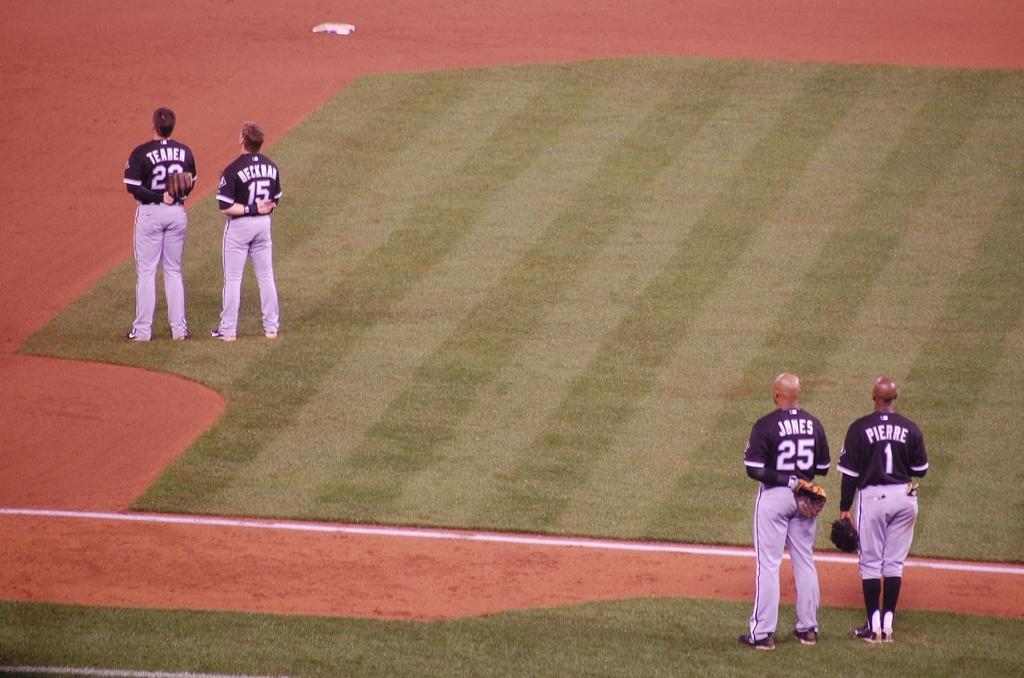How would you summarize this image in a sentence or two? In the picture we can see a playground with a green color mat on it and two players are standing in the front wearing a sports wear and other two are standing at the back. 